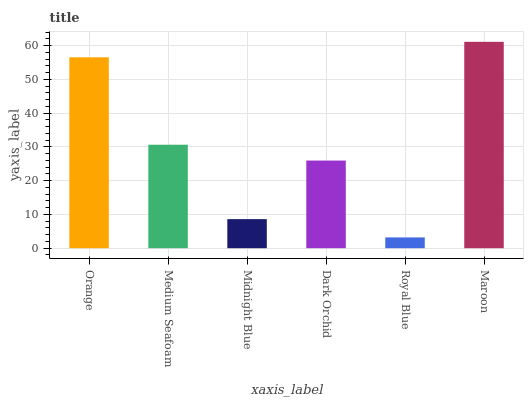Is Royal Blue the minimum?
Answer yes or no. Yes. Is Maroon the maximum?
Answer yes or no. Yes. Is Medium Seafoam the minimum?
Answer yes or no. No. Is Medium Seafoam the maximum?
Answer yes or no. No. Is Orange greater than Medium Seafoam?
Answer yes or no. Yes. Is Medium Seafoam less than Orange?
Answer yes or no. Yes. Is Medium Seafoam greater than Orange?
Answer yes or no. No. Is Orange less than Medium Seafoam?
Answer yes or no. No. Is Medium Seafoam the high median?
Answer yes or no. Yes. Is Dark Orchid the low median?
Answer yes or no. Yes. Is Dark Orchid the high median?
Answer yes or no. No. Is Midnight Blue the low median?
Answer yes or no. No. 